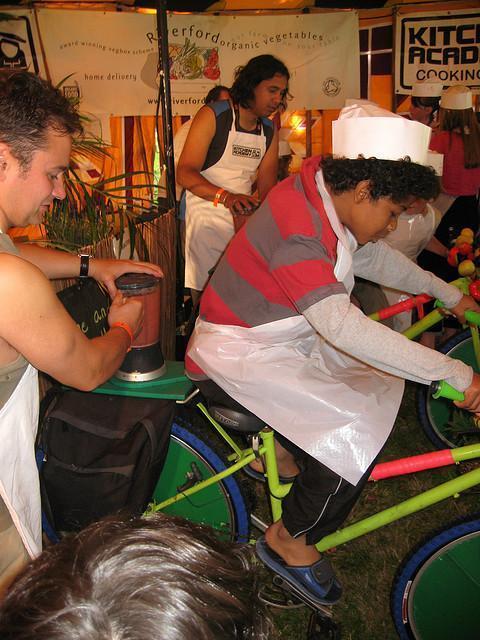How many people are in the picture?
Give a very brief answer. 6. 